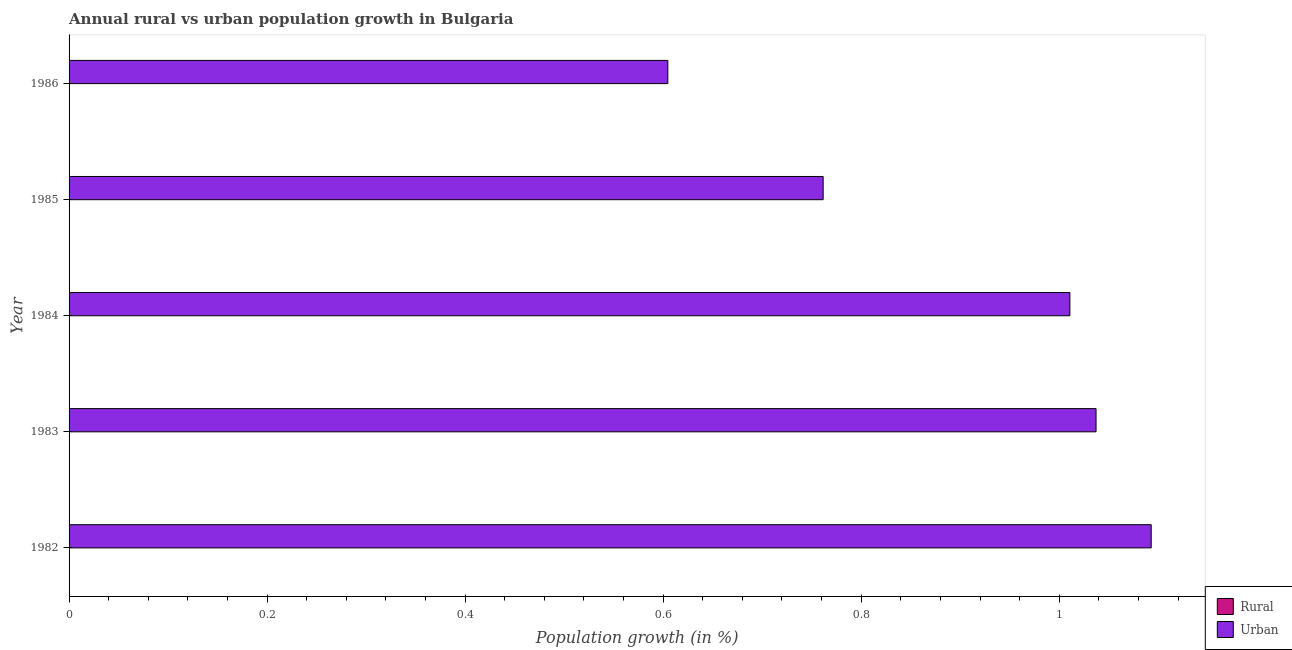Are the number of bars per tick equal to the number of legend labels?
Offer a very short reply. No. Are the number of bars on each tick of the Y-axis equal?
Provide a short and direct response. Yes. How many bars are there on the 1st tick from the bottom?
Provide a succinct answer. 1. In how many cases, is the number of bars for a given year not equal to the number of legend labels?
Provide a short and direct response. 5. What is the urban population growth in 1984?
Make the answer very short. 1.01. Across all years, what is the maximum urban population growth?
Give a very brief answer. 1.09. Across all years, what is the minimum urban population growth?
Your response must be concise. 0.6. What is the total urban population growth in the graph?
Offer a terse response. 4.51. What is the difference between the urban population growth in 1982 and that in 1986?
Provide a succinct answer. 0.49. What is the difference between the rural population growth in 1986 and the urban population growth in 1984?
Ensure brevity in your answer.  -1.01. What is the average urban population growth per year?
Your answer should be compact. 0.9. What is the ratio of the urban population growth in 1982 to that in 1985?
Provide a succinct answer. 1.44. What is the difference between the highest and the second highest urban population growth?
Offer a very short reply. 0.06. What is the difference between the highest and the lowest urban population growth?
Your answer should be very brief. 0.49. How many bars are there?
Offer a terse response. 5. How many years are there in the graph?
Provide a short and direct response. 5. Does the graph contain any zero values?
Your response must be concise. Yes. Where does the legend appear in the graph?
Make the answer very short. Bottom right. What is the title of the graph?
Give a very brief answer. Annual rural vs urban population growth in Bulgaria. Does "Commercial bank branches" appear as one of the legend labels in the graph?
Offer a very short reply. No. What is the label or title of the X-axis?
Make the answer very short. Population growth (in %). What is the Population growth (in %) of Rural in 1982?
Make the answer very short. 0. What is the Population growth (in %) of Urban  in 1982?
Make the answer very short. 1.09. What is the Population growth (in %) in Urban  in 1983?
Ensure brevity in your answer.  1.04. What is the Population growth (in %) of Rural in 1984?
Provide a succinct answer. 0. What is the Population growth (in %) in Urban  in 1984?
Make the answer very short. 1.01. What is the Population growth (in %) in Urban  in 1985?
Give a very brief answer. 0.76. What is the Population growth (in %) in Rural in 1986?
Offer a terse response. 0. What is the Population growth (in %) in Urban  in 1986?
Offer a very short reply. 0.6. Across all years, what is the maximum Population growth (in %) in Urban ?
Your answer should be very brief. 1.09. Across all years, what is the minimum Population growth (in %) of Urban ?
Ensure brevity in your answer.  0.6. What is the total Population growth (in %) of Rural in the graph?
Offer a very short reply. 0. What is the total Population growth (in %) of Urban  in the graph?
Provide a short and direct response. 4.51. What is the difference between the Population growth (in %) in Urban  in 1982 and that in 1983?
Your response must be concise. 0.06. What is the difference between the Population growth (in %) of Urban  in 1982 and that in 1984?
Provide a succinct answer. 0.08. What is the difference between the Population growth (in %) in Urban  in 1982 and that in 1985?
Offer a terse response. 0.33. What is the difference between the Population growth (in %) of Urban  in 1982 and that in 1986?
Provide a short and direct response. 0.49. What is the difference between the Population growth (in %) in Urban  in 1983 and that in 1984?
Your response must be concise. 0.03. What is the difference between the Population growth (in %) of Urban  in 1983 and that in 1985?
Your answer should be very brief. 0.28. What is the difference between the Population growth (in %) of Urban  in 1983 and that in 1986?
Your answer should be very brief. 0.43. What is the difference between the Population growth (in %) of Urban  in 1984 and that in 1985?
Provide a short and direct response. 0.25. What is the difference between the Population growth (in %) of Urban  in 1984 and that in 1986?
Keep it short and to the point. 0.41. What is the difference between the Population growth (in %) of Urban  in 1985 and that in 1986?
Your answer should be compact. 0.16. What is the average Population growth (in %) in Rural per year?
Ensure brevity in your answer.  0. What is the average Population growth (in %) in Urban  per year?
Offer a terse response. 0.9. What is the ratio of the Population growth (in %) in Urban  in 1982 to that in 1983?
Make the answer very short. 1.05. What is the ratio of the Population growth (in %) of Urban  in 1982 to that in 1984?
Keep it short and to the point. 1.08. What is the ratio of the Population growth (in %) of Urban  in 1982 to that in 1985?
Offer a terse response. 1.44. What is the ratio of the Population growth (in %) of Urban  in 1982 to that in 1986?
Ensure brevity in your answer.  1.81. What is the ratio of the Population growth (in %) in Urban  in 1983 to that in 1984?
Your response must be concise. 1.03. What is the ratio of the Population growth (in %) of Urban  in 1983 to that in 1985?
Provide a succinct answer. 1.36. What is the ratio of the Population growth (in %) in Urban  in 1983 to that in 1986?
Provide a short and direct response. 1.72. What is the ratio of the Population growth (in %) of Urban  in 1984 to that in 1985?
Offer a terse response. 1.33. What is the ratio of the Population growth (in %) in Urban  in 1984 to that in 1986?
Ensure brevity in your answer.  1.67. What is the ratio of the Population growth (in %) of Urban  in 1985 to that in 1986?
Your response must be concise. 1.26. What is the difference between the highest and the second highest Population growth (in %) of Urban ?
Offer a terse response. 0.06. What is the difference between the highest and the lowest Population growth (in %) in Urban ?
Offer a terse response. 0.49. 